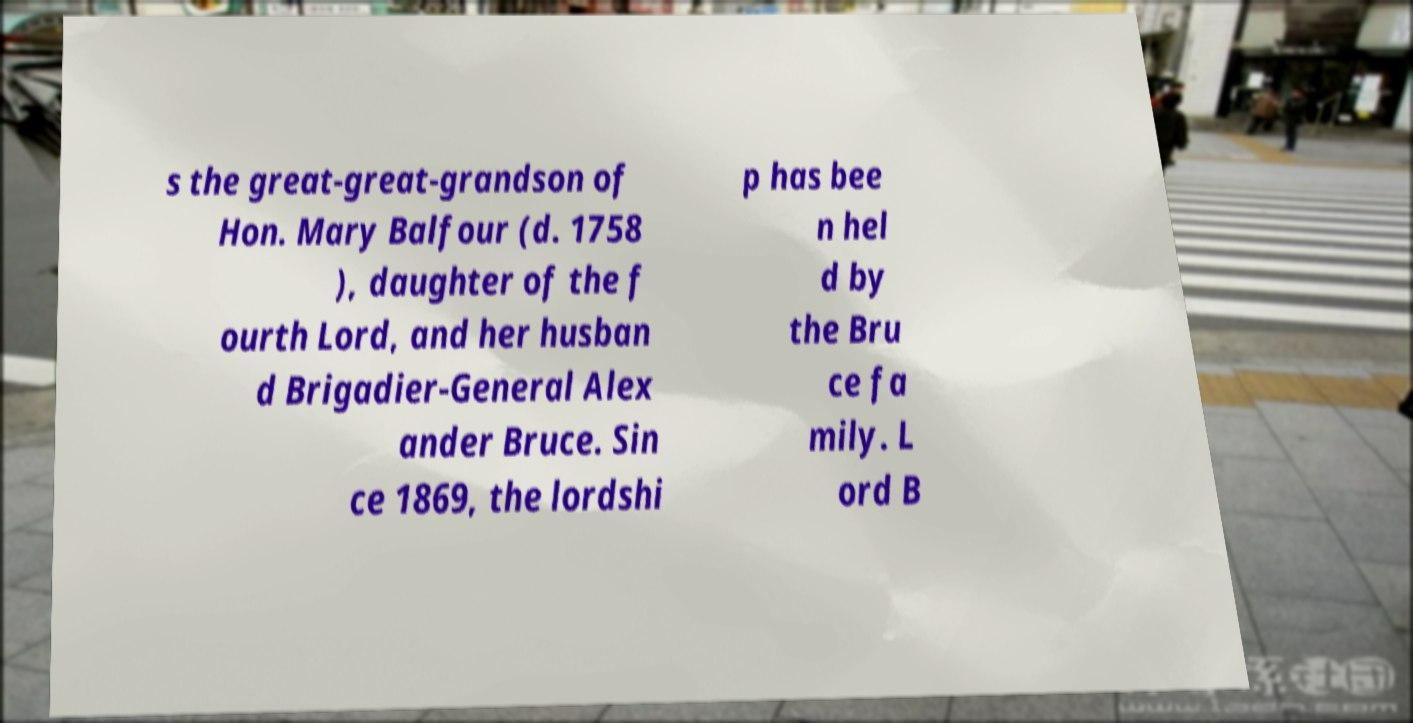Please read and relay the text visible in this image. What does it say? s the great-great-grandson of Hon. Mary Balfour (d. 1758 ), daughter of the f ourth Lord, and her husban d Brigadier-General Alex ander Bruce. Sin ce 1869, the lordshi p has bee n hel d by the Bru ce fa mily. L ord B 